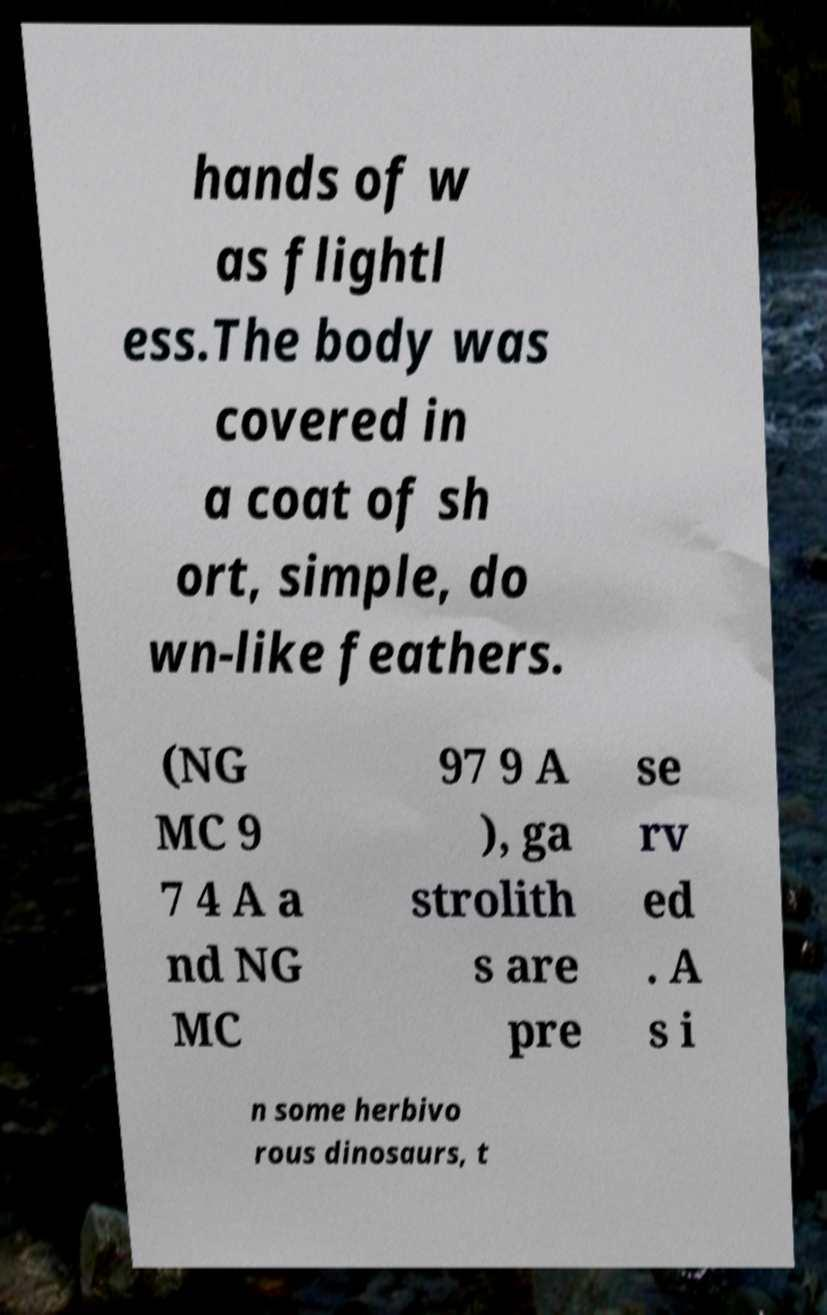Could you extract and type out the text from this image? hands of w as flightl ess.The body was covered in a coat of sh ort, simple, do wn-like feathers. (NG MC 9 7 4 A a nd NG MC 97 9 A ), ga strolith s are pre se rv ed . A s i n some herbivo rous dinosaurs, t 